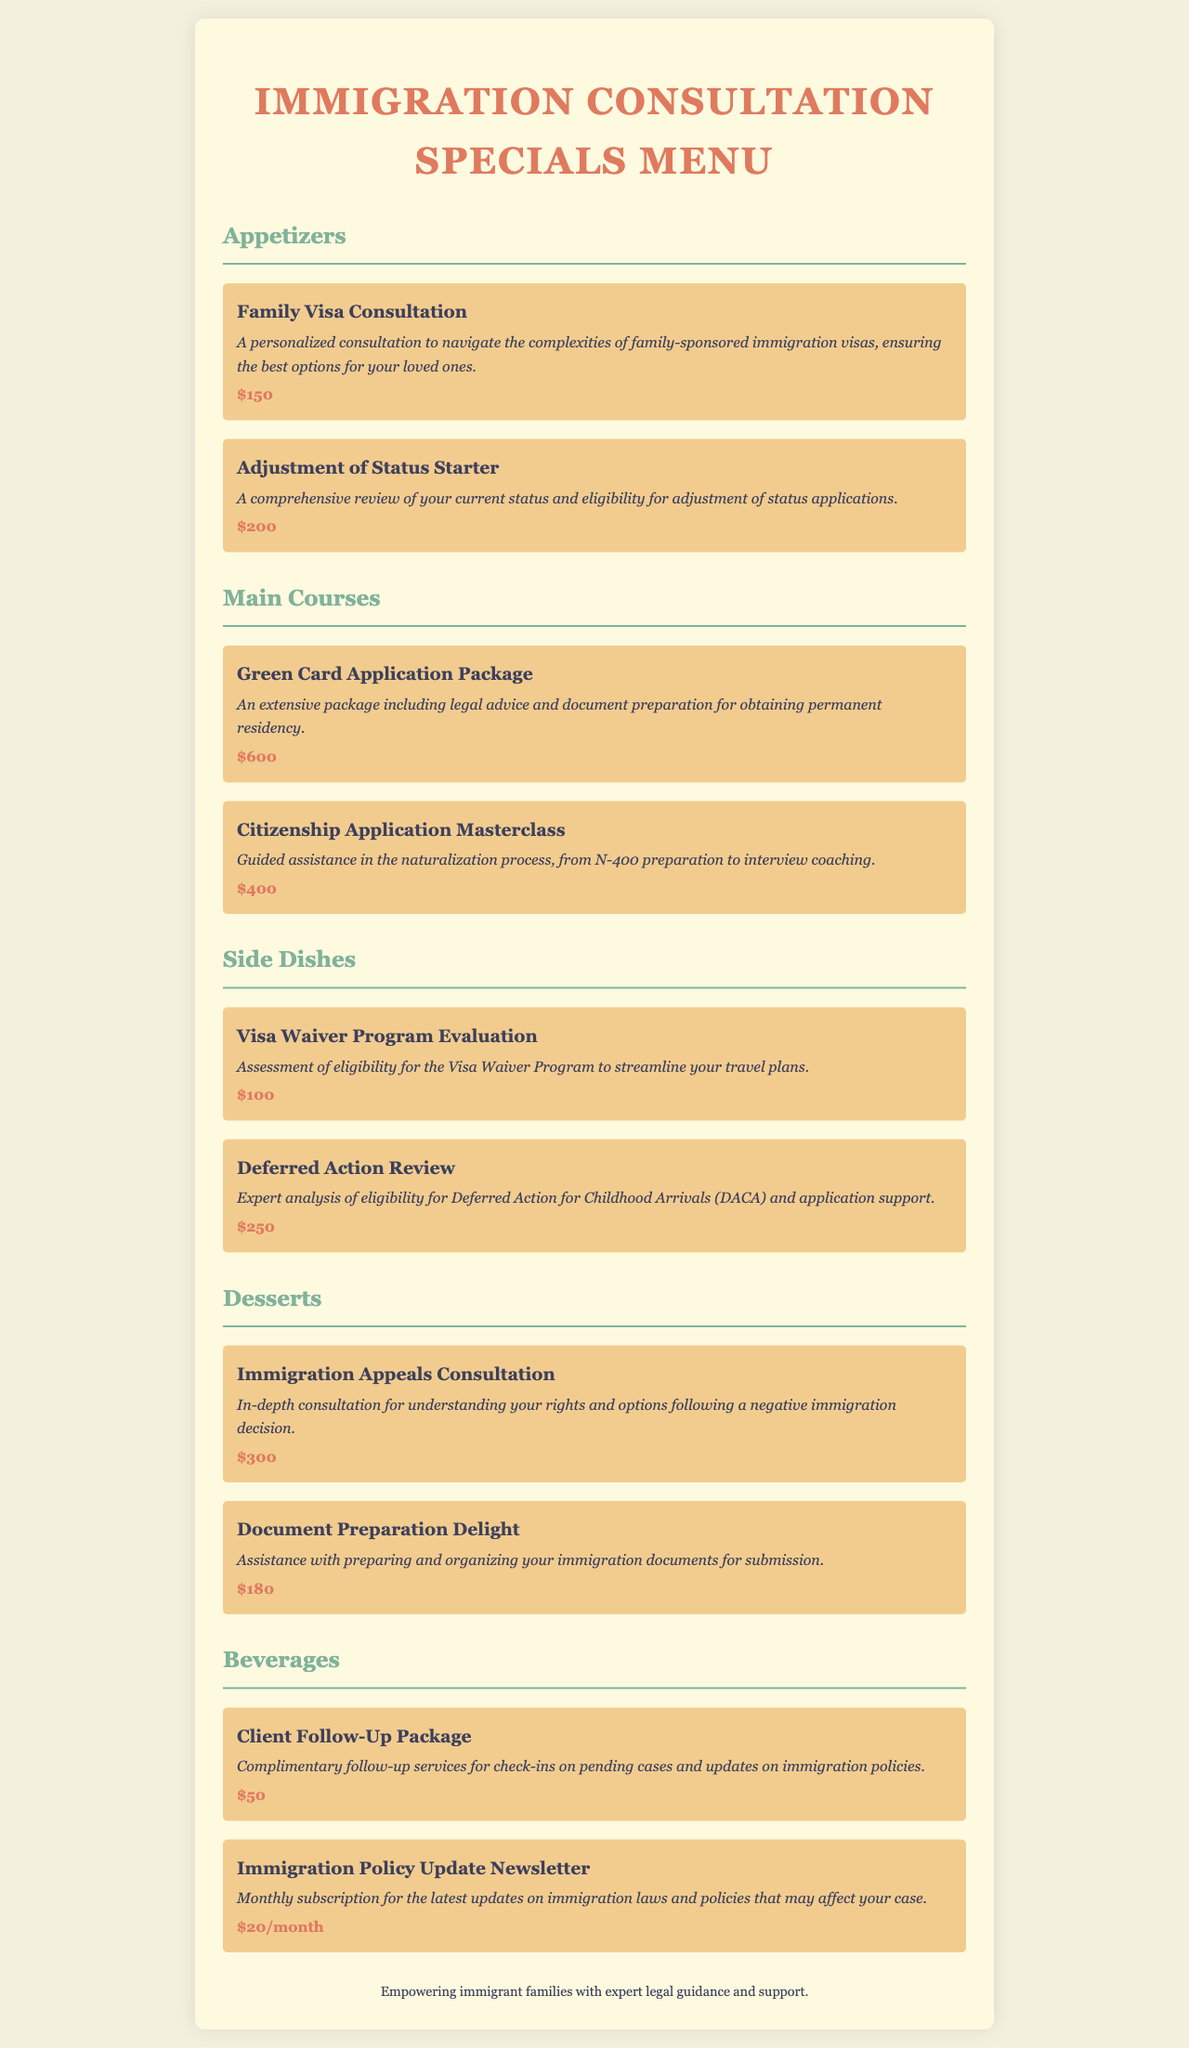What is the price of the Family Visa Consultation? The price is explicitly stated next to the Family Visa Consultation item in the document.
Answer: $150 How many Main Courses are listed in the menu? By counting the items under the Main Courses section, we can determine that there are two items.
Answer: 2 What is included in the Green Card Application Package? The description for this item states the contents clearly, encompassing legal advice and document preparation.
Answer: Legal advice and document preparation What is the price of the Deferred Action Review? The price is listed directly next to the Deferred Action Review item.
Answer: $250 What consultation focuses on immigration appeals? The Immigration Appeals Consultation is mentioned in the Desserts section as focusing on this matter.
Answer: Immigration Appeals Consultation Which beverage offers complimentary follow-up services? The Client Follow-Up Package is specifically mentioned to provide these services.
Answer: Client Follow-Up Package What is the monthly cost for the Immigration Policy Update Newsletter? The document specifies that this subscription has a monthly fee.
Answer: $20/month What is the highest-priced item on the menu? By comparing all listed prices, the highest one can be identified.
Answer: $600 What type of assistance is provided in the Citizenship Application Masterclass? The description indicates that it's guided assistance through the naturalization process.
Answer: Guided assistance in the naturalization process 